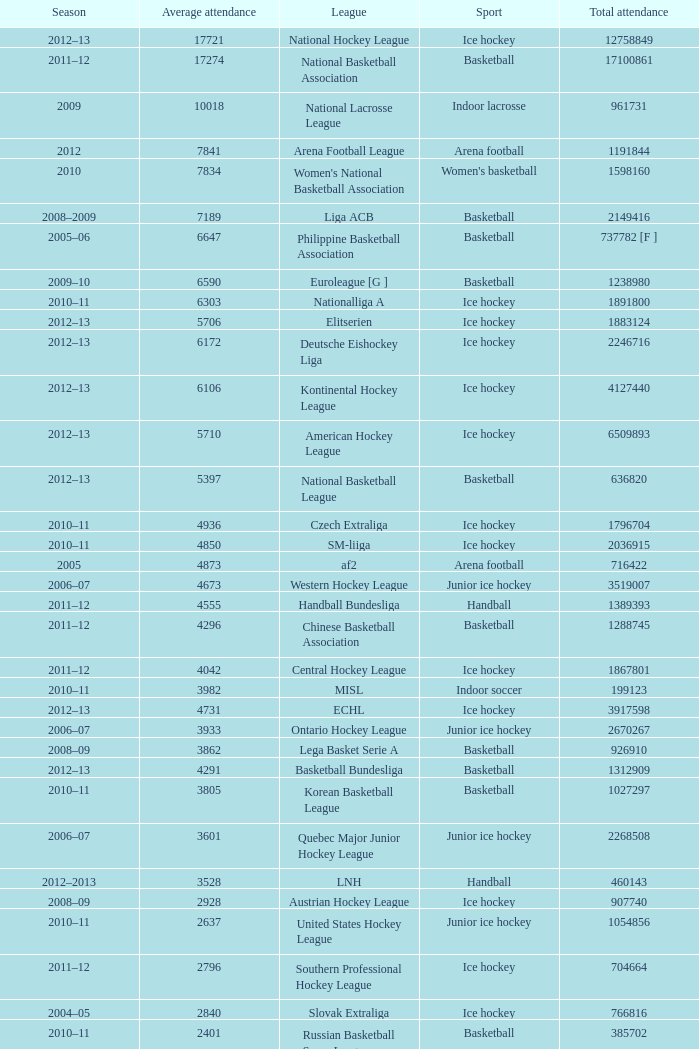What's the average attendance of the league with a total attendance of 2268508? 3601.0. 